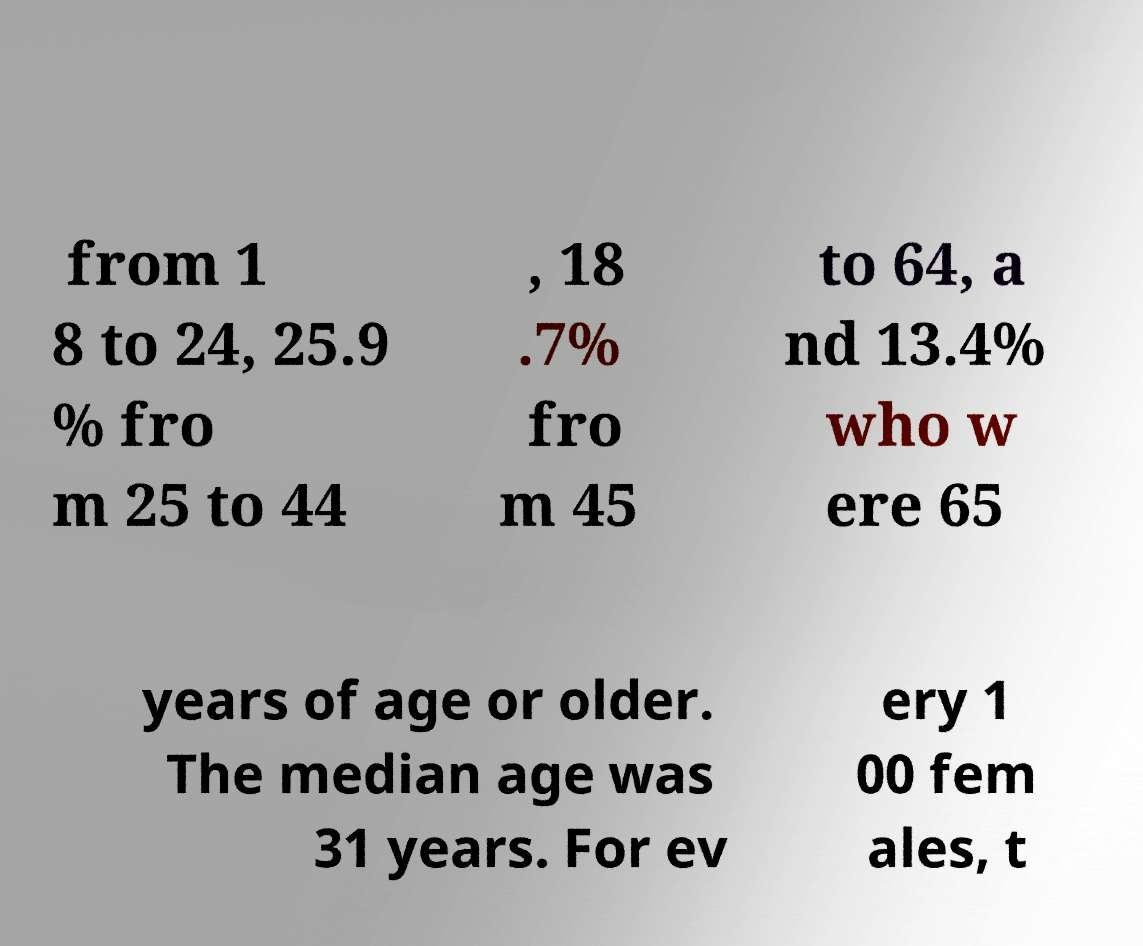Please read and relay the text visible in this image. What does it say? from 1 8 to 24, 25.9 % fro m 25 to 44 , 18 .7% fro m 45 to 64, a nd 13.4% who w ere 65 years of age or older. The median age was 31 years. For ev ery 1 00 fem ales, t 